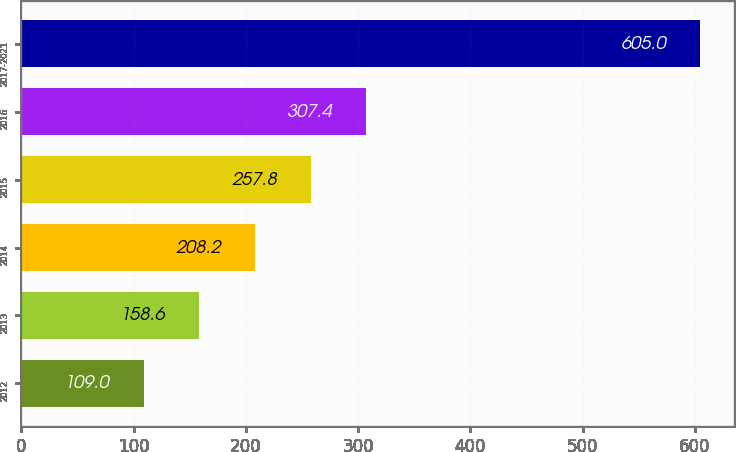<chart> <loc_0><loc_0><loc_500><loc_500><bar_chart><fcel>2012<fcel>2013<fcel>2014<fcel>2015<fcel>2016<fcel>2017-2021<nl><fcel>109<fcel>158.6<fcel>208.2<fcel>257.8<fcel>307.4<fcel>605<nl></chart> 